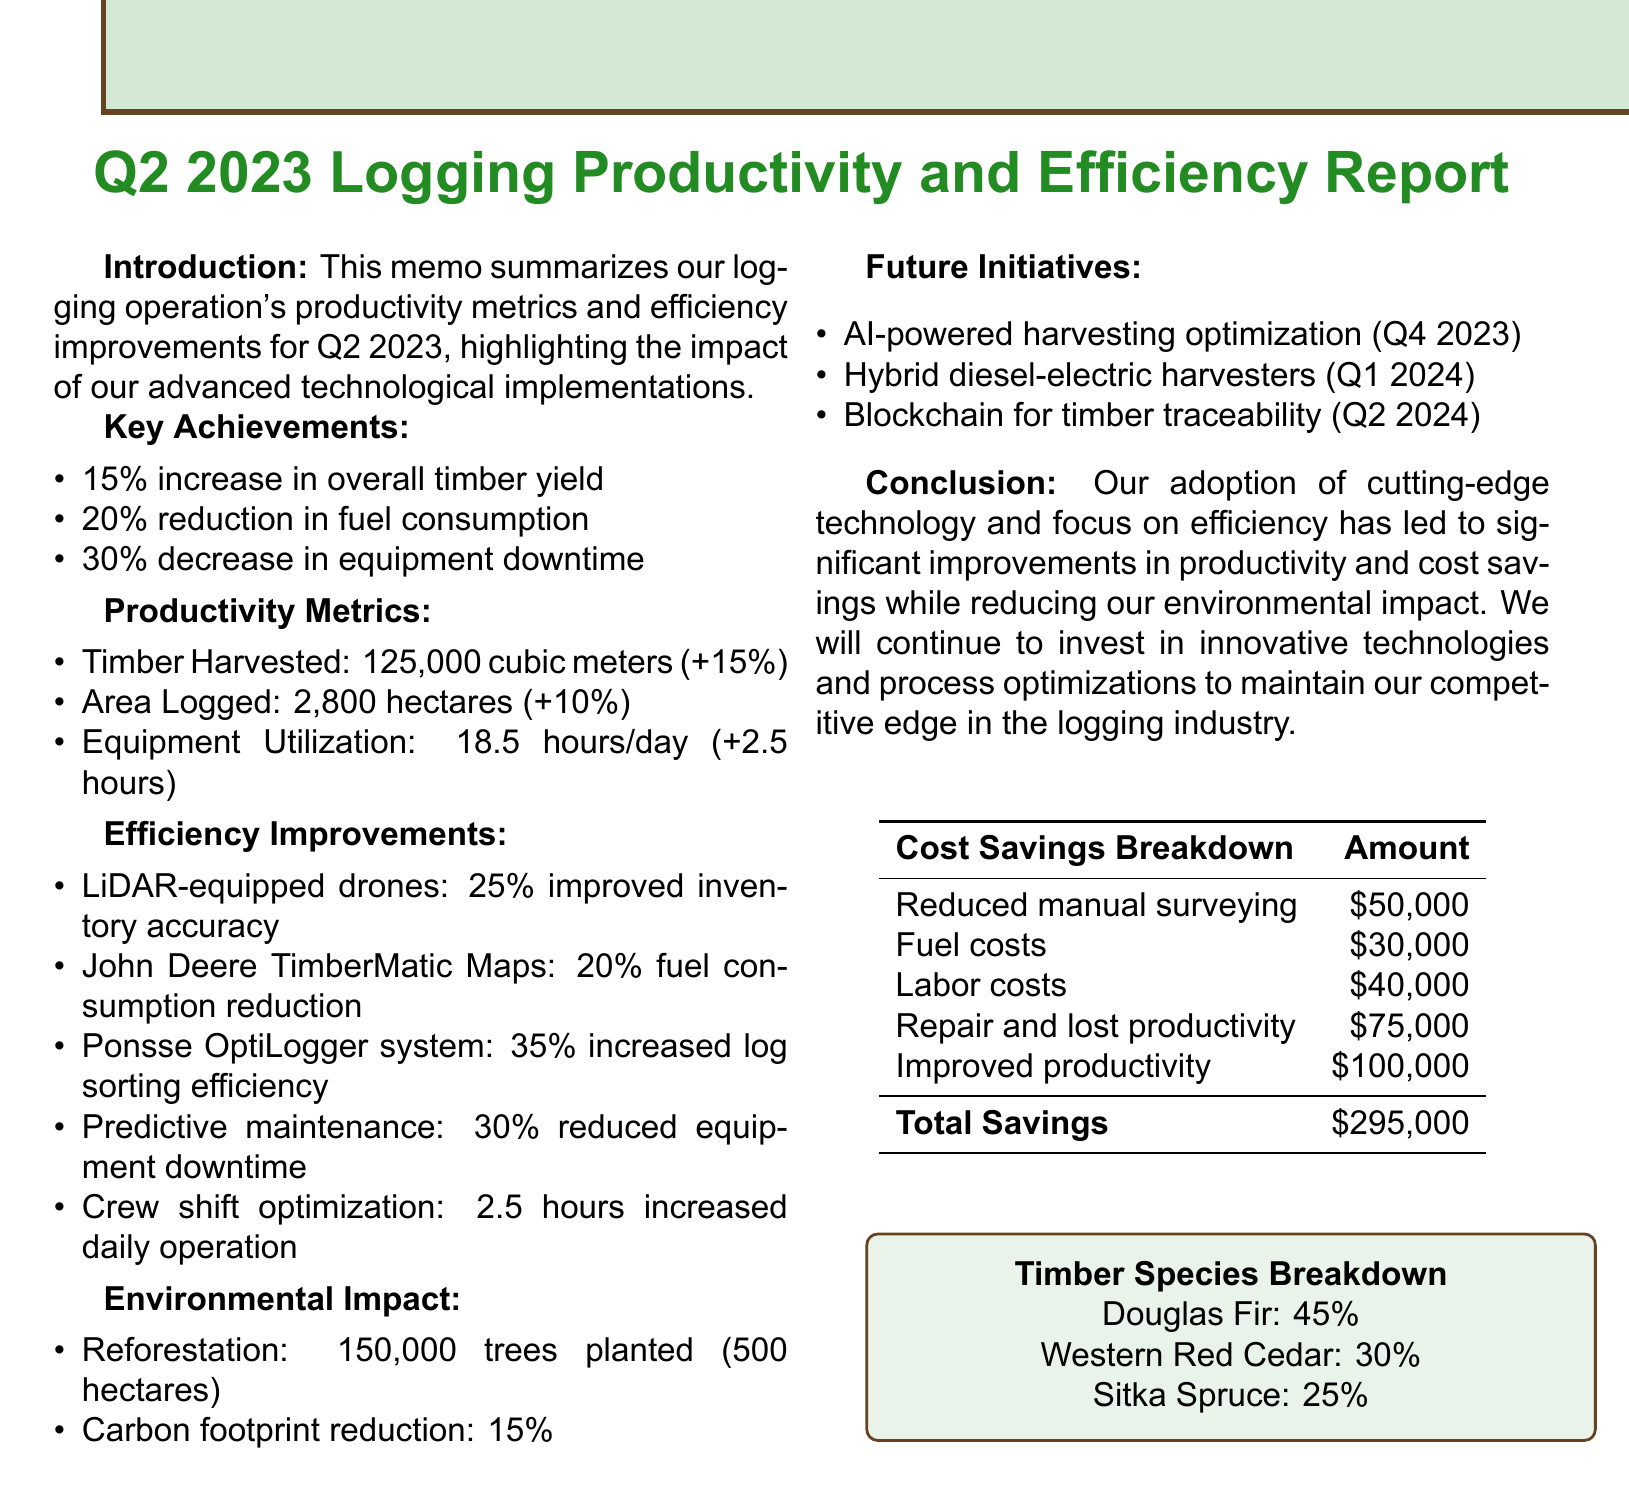What is the total volume of timber harvested? The total volume of timber harvested is stated in the productivity metrics section of the document as 125,000 cubic meters.
Answer: 125,000 cubic meters What was the percentage increase in overall timber yield? The percentage increase in overall timber yield is mentioned in the key achievements section of the document as 15%.
Answer: 15% How many hectares were logged in Q2 2023? The total area logged is specified in the productivity metrics section of the document as 2,800 hectares.
Answer: 2,800 hectares What technology improved forest inventory accuracy? The technology that improved forest inventory accuracy is listed in the efficiency improvements section as LiDAR-equipped drones.
Answer: LiDAR-equipped drones What is the expected impact of AI-powered harvesting optimization? The expected impact of AI-powered harvesting optimization is provided in the future initiatives section as a 10% increase in timber yield.
Answer: 10% increase in timber yield What was the total cost savings recorded? The total cost savings is calculated from various savings listed in the cost savings breakdown table in the document, which sums to $295,000.
Answer: $295,000 Which tree species had the highest percentage harvested? The tree species with the highest percentage harvested is Douglas Fir, noted in the timber species breakdown in the document as 45%.
Answer: Douglas Fir How much was saved from improved productivity? The amount saved from improved productivity is stated in the cost savings breakdown as $100,000.
Answer: $100,000 